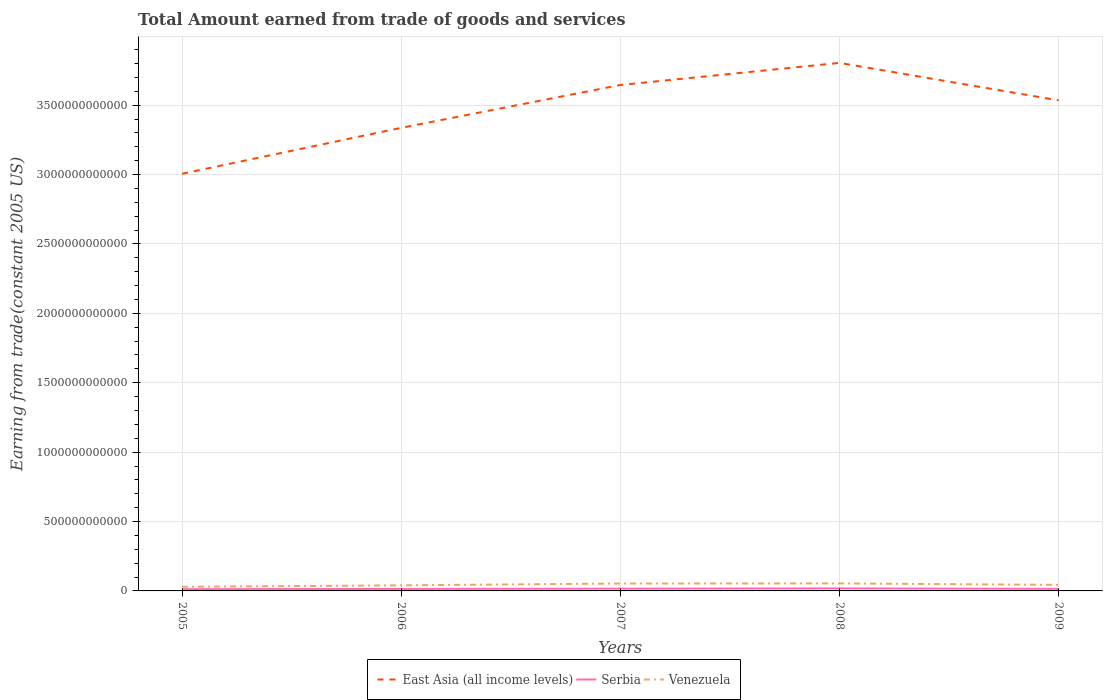How many different coloured lines are there?
Make the answer very short. 3. Across all years, what is the maximum total amount earned by trading goods and services in Serbia?
Provide a succinct answer. 1.24e+1. In which year was the total amount earned by trading goods and services in Serbia maximum?
Ensure brevity in your answer.  2005. What is the total total amount earned by trading goods and services in Serbia in the graph?
Provide a short and direct response. -4.27e+09. What is the difference between the highest and the second highest total amount earned by trading goods and services in Venezuela?
Offer a terse response. 2.43e+1. How many years are there in the graph?
Offer a very short reply. 5. What is the difference between two consecutive major ticks on the Y-axis?
Provide a short and direct response. 5.00e+11. Does the graph contain any zero values?
Provide a succinct answer. No. Where does the legend appear in the graph?
Ensure brevity in your answer.  Bottom center. How many legend labels are there?
Your answer should be compact. 3. How are the legend labels stacked?
Your answer should be compact. Horizontal. What is the title of the graph?
Your answer should be compact. Total Amount earned from trade of goods and services. What is the label or title of the X-axis?
Ensure brevity in your answer.  Years. What is the label or title of the Y-axis?
Offer a very short reply. Earning from trade(constant 2005 US). What is the Earning from trade(constant 2005 US) in East Asia (all income levels) in 2005?
Ensure brevity in your answer.  3.01e+12. What is the Earning from trade(constant 2005 US) in Serbia in 2005?
Offer a very short reply. 1.24e+1. What is the Earning from trade(constant 2005 US) of Venezuela in 2005?
Keep it short and to the point. 2.98e+1. What is the Earning from trade(constant 2005 US) in East Asia (all income levels) in 2006?
Keep it short and to the point. 3.34e+12. What is the Earning from trade(constant 2005 US) of Serbia in 2006?
Your answer should be compact. 1.42e+1. What is the Earning from trade(constant 2005 US) of Venezuela in 2006?
Your answer should be very brief. 4.01e+1. What is the Earning from trade(constant 2005 US) in East Asia (all income levels) in 2007?
Your answer should be very brief. 3.65e+12. What is the Earning from trade(constant 2005 US) of Serbia in 2007?
Offer a very short reply. 1.65e+1. What is the Earning from trade(constant 2005 US) in Venezuela in 2007?
Your response must be concise. 5.34e+1. What is the Earning from trade(constant 2005 US) in East Asia (all income levels) in 2008?
Make the answer very short. 3.80e+12. What is the Earning from trade(constant 2005 US) in Serbia in 2008?
Your response must be concise. 1.85e+1. What is the Earning from trade(constant 2005 US) in Venezuela in 2008?
Make the answer very short. 5.41e+1. What is the Earning from trade(constant 2005 US) in East Asia (all income levels) in 2009?
Your response must be concise. 3.53e+12. What is the Earning from trade(constant 2005 US) of Serbia in 2009?
Offer a terse response. 1.49e+1. What is the Earning from trade(constant 2005 US) in Venezuela in 2009?
Provide a short and direct response. 4.35e+1. Across all years, what is the maximum Earning from trade(constant 2005 US) in East Asia (all income levels)?
Your answer should be very brief. 3.80e+12. Across all years, what is the maximum Earning from trade(constant 2005 US) in Serbia?
Keep it short and to the point. 1.85e+1. Across all years, what is the maximum Earning from trade(constant 2005 US) in Venezuela?
Offer a terse response. 5.41e+1. Across all years, what is the minimum Earning from trade(constant 2005 US) in East Asia (all income levels)?
Offer a very short reply. 3.01e+12. Across all years, what is the minimum Earning from trade(constant 2005 US) of Serbia?
Provide a succinct answer. 1.24e+1. Across all years, what is the minimum Earning from trade(constant 2005 US) in Venezuela?
Make the answer very short. 2.98e+1. What is the total Earning from trade(constant 2005 US) in East Asia (all income levels) in the graph?
Your answer should be compact. 1.73e+13. What is the total Earning from trade(constant 2005 US) in Serbia in the graph?
Your response must be concise. 7.65e+1. What is the total Earning from trade(constant 2005 US) in Venezuela in the graph?
Offer a terse response. 2.21e+11. What is the difference between the Earning from trade(constant 2005 US) of East Asia (all income levels) in 2005 and that in 2006?
Provide a succinct answer. -3.31e+11. What is the difference between the Earning from trade(constant 2005 US) of Serbia in 2005 and that in 2006?
Offer a terse response. -1.85e+09. What is the difference between the Earning from trade(constant 2005 US) in Venezuela in 2005 and that in 2006?
Provide a short and direct response. -1.04e+1. What is the difference between the Earning from trade(constant 2005 US) in East Asia (all income levels) in 2005 and that in 2007?
Your answer should be very brief. -6.40e+11. What is the difference between the Earning from trade(constant 2005 US) in Serbia in 2005 and that in 2007?
Provide a short and direct response. -4.13e+09. What is the difference between the Earning from trade(constant 2005 US) of Venezuela in 2005 and that in 2007?
Your answer should be very brief. -2.36e+1. What is the difference between the Earning from trade(constant 2005 US) of East Asia (all income levels) in 2005 and that in 2008?
Your answer should be very brief. -7.99e+11. What is the difference between the Earning from trade(constant 2005 US) of Serbia in 2005 and that in 2008?
Keep it short and to the point. -6.12e+09. What is the difference between the Earning from trade(constant 2005 US) in Venezuela in 2005 and that in 2008?
Keep it short and to the point. -2.43e+1. What is the difference between the Earning from trade(constant 2005 US) in East Asia (all income levels) in 2005 and that in 2009?
Your answer should be very brief. -5.29e+11. What is the difference between the Earning from trade(constant 2005 US) of Serbia in 2005 and that in 2009?
Give a very brief answer. -2.49e+09. What is the difference between the Earning from trade(constant 2005 US) in Venezuela in 2005 and that in 2009?
Give a very brief answer. -1.37e+1. What is the difference between the Earning from trade(constant 2005 US) in East Asia (all income levels) in 2006 and that in 2007?
Keep it short and to the point. -3.09e+11. What is the difference between the Earning from trade(constant 2005 US) of Serbia in 2006 and that in 2007?
Offer a terse response. -2.29e+09. What is the difference between the Earning from trade(constant 2005 US) of Venezuela in 2006 and that in 2007?
Your answer should be very brief. -1.32e+1. What is the difference between the Earning from trade(constant 2005 US) of East Asia (all income levels) in 2006 and that in 2008?
Your response must be concise. -4.68e+11. What is the difference between the Earning from trade(constant 2005 US) of Serbia in 2006 and that in 2008?
Ensure brevity in your answer.  -4.27e+09. What is the difference between the Earning from trade(constant 2005 US) in Venezuela in 2006 and that in 2008?
Offer a terse response. -1.40e+1. What is the difference between the Earning from trade(constant 2005 US) in East Asia (all income levels) in 2006 and that in 2009?
Give a very brief answer. -1.98e+11. What is the difference between the Earning from trade(constant 2005 US) in Serbia in 2006 and that in 2009?
Keep it short and to the point. -6.40e+08. What is the difference between the Earning from trade(constant 2005 US) of Venezuela in 2006 and that in 2009?
Your response must be concise. -3.39e+09. What is the difference between the Earning from trade(constant 2005 US) of East Asia (all income levels) in 2007 and that in 2008?
Offer a terse response. -1.59e+11. What is the difference between the Earning from trade(constant 2005 US) in Serbia in 2007 and that in 2008?
Give a very brief answer. -1.98e+09. What is the difference between the Earning from trade(constant 2005 US) of Venezuela in 2007 and that in 2008?
Keep it short and to the point. -7.27e+08. What is the difference between the Earning from trade(constant 2005 US) of East Asia (all income levels) in 2007 and that in 2009?
Provide a succinct answer. 1.11e+11. What is the difference between the Earning from trade(constant 2005 US) of Serbia in 2007 and that in 2009?
Your answer should be very brief. 1.65e+09. What is the difference between the Earning from trade(constant 2005 US) of Venezuela in 2007 and that in 2009?
Make the answer very short. 9.86e+09. What is the difference between the Earning from trade(constant 2005 US) in East Asia (all income levels) in 2008 and that in 2009?
Give a very brief answer. 2.70e+11. What is the difference between the Earning from trade(constant 2005 US) of Serbia in 2008 and that in 2009?
Your answer should be compact. 3.63e+09. What is the difference between the Earning from trade(constant 2005 US) in Venezuela in 2008 and that in 2009?
Provide a short and direct response. 1.06e+1. What is the difference between the Earning from trade(constant 2005 US) of East Asia (all income levels) in 2005 and the Earning from trade(constant 2005 US) of Serbia in 2006?
Offer a terse response. 2.99e+12. What is the difference between the Earning from trade(constant 2005 US) in East Asia (all income levels) in 2005 and the Earning from trade(constant 2005 US) in Venezuela in 2006?
Your answer should be compact. 2.97e+12. What is the difference between the Earning from trade(constant 2005 US) of Serbia in 2005 and the Earning from trade(constant 2005 US) of Venezuela in 2006?
Your response must be concise. -2.78e+1. What is the difference between the Earning from trade(constant 2005 US) of East Asia (all income levels) in 2005 and the Earning from trade(constant 2005 US) of Serbia in 2007?
Your response must be concise. 2.99e+12. What is the difference between the Earning from trade(constant 2005 US) in East Asia (all income levels) in 2005 and the Earning from trade(constant 2005 US) in Venezuela in 2007?
Ensure brevity in your answer.  2.95e+12. What is the difference between the Earning from trade(constant 2005 US) of Serbia in 2005 and the Earning from trade(constant 2005 US) of Venezuela in 2007?
Make the answer very short. -4.10e+1. What is the difference between the Earning from trade(constant 2005 US) in East Asia (all income levels) in 2005 and the Earning from trade(constant 2005 US) in Serbia in 2008?
Provide a short and direct response. 2.99e+12. What is the difference between the Earning from trade(constant 2005 US) of East Asia (all income levels) in 2005 and the Earning from trade(constant 2005 US) of Venezuela in 2008?
Your answer should be very brief. 2.95e+12. What is the difference between the Earning from trade(constant 2005 US) in Serbia in 2005 and the Earning from trade(constant 2005 US) in Venezuela in 2008?
Ensure brevity in your answer.  -4.17e+1. What is the difference between the Earning from trade(constant 2005 US) of East Asia (all income levels) in 2005 and the Earning from trade(constant 2005 US) of Serbia in 2009?
Offer a very short reply. 2.99e+12. What is the difference between the Earning from trade(constant 2005 US) of East Asia (all income levels) in 2005 and the Earning from trade(constant 2005 US) of Venezuela in 2009?
Keep it short and to the point. 2.96e+12. What is the difference between the Earning from trade(constant 2005 US) of Serbia in 2005 and the Earning from trade(constant 2005 US) of Venezuela in 2009?
Provide a succinct answer. -3.12e+1. What is the difference between the Earning from trade(constant 2005 US) in East Asia (all income levels) in 2006 and the Earning from trade(constant 2005 US) in Serbia in 2007?
Your response must be concise. 3.32e+12. What is the difference between the Earning from trade(constant 2005 US) of East Asia (all income levels) in 2006 and the Earning from trade(constant 2005 US) of Venezuela in 2007?
Your response must be concise. 3.28e+12. What is the difference between the Earning from trade(constant 2005 US) in Serbia in 2006 and the Earning from trade(constant 2005 US) in Venezuela in 2007?
Make the answer very short. -3.92e+1. What is the difference between the Earning from trade(constant 2005 US) in East Asia (all income levels) in 2006 and the Earning from trade(constant 2005 US) in Serbia in 2008?
Offer a terse response. 3.32e+12. What is the difference between the Earning from trade(constant 2005 US) of East Asia (all income levels) in 2006 and the Earning from trade(constant 2005 US) of Venezuela in 2008?
Provide a succinct answer. 3.28e+12. What is the difference between the Earning from trade(constant 2005 US) in Serbia in 2006 and the Earning from trade(constant 2005 US) in Venezuela in 2008?
Your answer should be compact. -3.99e+1. What is the difference between the Earning from trade(constant 2005 US) in East Asia (all income levels) in 2006 and the Earning from trade(constant 2005 US) in Serbia in 2009?
Ensure brevity in your answer.  3.32e+12. What is the difference between the Earning from trade(constant 2005 US) in East Asia (all income levels) in 2006 and the Earning from trade(constant 2005 US) in Venezuela in 2009?
Give a very brief answer. 3.29e+12. What is the difference between the Earning from trade(constant 2005 US) of Serbia in 2006 and the Earning from trade(constant 2005 US) of Venezuela in 2009?
Provide a short and direct response. -2.93e+1. What is the difference between the Earning from trade(constant 2005 US) in East Asia (all income levels) in 2007 and the Earning from trade(constant 2005 US) in Serbia in 2008?
Ensure brevity in your answer.  3.63e+12. What is the difference between the Earning from trade(constant 2005 US) of East Asia (all income levels) in 2007 and the Earning from trade(constant 2005 US) of Venezuela in 2008?
Your answer should be compact. 3.59e+12. What is the difference between the Earning from trade(constant 2005 US) of Serbia in 2007 and the Earning from trade(constant 2005 US) of Venezuela in 2008?
Your answer should be compact. -3.76e+1. What is the difference between the Earning from trade(constant 2005 US) in East Asia (all income levels) in 2007 and the Earning from trade(constant 2005 US) in Serbia in 2009?
Ensure brevity in your answer.  3.63e+12. What is the difference between the Earning from trade(constant 2005 US) of East Asia (all income levels) in 2007 and the Earning from trade(constant 2005 US) of Venezuela in 2009?
Provide a succinct answer. 3.60e+12. What is the difference between the Earning from trade(constant 2005 US) of Serbia in 2007 and the Earning from trade(constant 2005 US) of Venezuela in 2009?
Your answer should be very brief. -2.70e+1. What is the difference between the Earning from trade(constant 2005 US) in East Asia (all income levels) in 2008 and the Earning from trade(constant 2005 US) in Serbia in 2009?
Provide a short and direct response. 3.79e+12. What is the difference between the Earning from trade(constant 2005 US) of East Asia (all income levels) in 2008 and the Earning from trade(constant 2005 US) of Venezuela in 2009?
Keep it short and to the point. 3.76e+12. What is the difference between the Earning from trade(constant 2005 US) of Serbia in 2008 and the Earning from trade(constant 2005 US) of Venezuela in 2009?
Ensure brevity in your answer.  -2.50e+1. What is the average Earning from trade(constant 2005 US) of East Asia (all income levels) per year?
Keep it short and to the point. 3.47e+12. What is the average Earning from trade(constant 2005 US) in Serbia per year?
Make the answer very short. 1.53e+1. What is the average Earning from trade(constant 2005 US) of Venezuela per year?
Offer a very short reply. 4.42e+1. In the year 2005, what is the difference between the Earning from trade(constant 2005 US) of East Asia (all income levels) and Earning from trade(constant 2005 US) of Serbia?
Make the answer very short. 2.99e+12. In the year 2005, what is the difference between the Earning from trade(constant 2005 US) in East Asia (all income levels) and Earning from trade(constant 2005 US) in Venezuela?
Your response must be concise. 2.98e+12. In the year 2005, what is the difference between the Earning from trade(constant 2005 US) in Serbia and Earning from trade(constant 2005 US) in Venezuela?
Your answer should be very brief. -1.74e+1. In the year 2006, what is the difference between the Earning from trade(constant 2005 US) in East Asia (all income levels) and Earning from trade(constant 2005 US) in Serbia?
Your answer should be compact. 3.32e+12. In the year 2006, what is the difference between the Earning from trade(constant 2005 US) in East Asia (all income levels) and Earning from trade(constant 2005 US) in Venezuela?
Provide a short and direct response. 3.30e+12. In the year 2006, what is the difference between the Earning from trade(constant 2005 US) of Serbia and Earning from trade(constant 2005 US) of Venezuela?
Ensure brevity in your answer.  -2.59e+1. In the year 2007, what is the difference between the Earning from trade(constant 2005 US) in East Asia (all income levels) and Earning from trade(constant 2005 US) in Serbia?
Offer a very short reply. 3.63e+12. In the year 2007, what is the difference between the Earning from trade(constant 2005 US) of East Asia (all income levels) and Earning from trade(constant 2005 US) of Venezuela?
Give a very brief answer. 3.59e+12. In the year 2007, what is the difference between the Earning from trade(constant 2005 US) of Serbia and Earning from trade(constant 2005 US) of Venezuela?
Ensure brevity in your answer.  -3.69e+1. In the year 2008, what is the difference between the Earning from trade(constant 2005 US) of East Asia (all income levels) and Earning from trade(constant 2005 US) of Serbia?
Your answer should be very brief. 3.79e+12. In the year 2008, what is the difference between the Earning from trade(constant 2005 US) of East Asia (all income levels) and Earning from trade(constant 2005 US) of Venezuela?
Your answer should be compact. 3.75e+12. In the year 2008, what is the difference between the Earning from trade(constant 2005 US) in Serbia and Earning from trade(constant 2005 US) in Venezuela?
Provide a short and direct response. -3.56e+1. In the year 2009, what is the difference between the Earning from trade(constant 2005 US) in East Asia (all income levels) and Earning from trade(constant 2005 US) in Serbia?
Provide a short and direct response. 3.52e+12. In the year 2009, what is the difference between the Earning from trade(constant 2005 US) in East Asia (all income levels) and Earning from trade(constant 2005 US) in Venezuela?
Provide a succinct answer. 3.49e+12. In the year 2009, what is the difference between the Earning from trade(constant 2005 US) in Serbia and Earning from trade(constant 2005 US) in Venezuela?
Provide a short and direct response. -2.87e+1. What is the ratio of the Earning from trade(constant 2005 US) in East Asia (all income levels) in 2005 to that in 2006?
Offer a terse response. 0.9. What is the ratio of the Earning from trade(constant 2005 US) of Serbia in 2005 to that in 2006?
Your response must be concise. 0.87. What is the ratio of the Earning from trade(constant 2005 US) of Venezuela in 2005 to that in 2006?
Your response must be concise. 0.74. What is the ratio of the Earning from trade(constant 2005 US) in East Asia (all income levels) in 2005 to that in 2007?
Your response must be concise. 0.82. What is the ratio of the Earning from trade(constant 2005 US) in Serbia in 2005 to that in 2007?
Your answer should be compact. 0.75. What is the ratio of the Earning from trade(constant 2005 US) of Venezuela in 2005 to that in 2007?
Ensure brevity in your answer.  0.56. What is the ratio of the Earning from trade(constant 2005 US) in East Asia (all income levels) in 2005 to that in 2008?
Offer a very short reply. 0.79. What is the ratio of the Earning from trade(constant 2005 US) of Serbia in 2005 to that in 2008?
Provide a short and direct response. 0.67. What is the ratio of the Earning from trade(constant 2005 US) of Venezuela in 2005 to that in 2008?
Offer a very short reply. 0.55. What is the ratio of the Earning from trade(constant 2005 US) of East Asia (all income levels) in 2005 to that in 2009?
Give a very brief answer. 0.85. What is the ratio of the Earning from trade(constant 2005 US) of Serbia in 2005 to that in 2009?
Offer a terse response. 0.83. What is the ratio of the Earning from trade(constant 2005 US) of Venezuela in 2005 to that in 2009?
Give a very brief answer. 0.68. What is the ratio of the Earning from trade(constant 2005 US) of East Asia (all income levels) in 2006 to that in 2007?
Provide a succinct answer. 0.92. What is the ratio of the Earning from trade(constant 2005 US) of Serbia in 2006 to that in 2007?
Give a very brief answer. 0.86. What is the ratio of the Earning from trade(constant 2005 US) in Venezuela in 2006 to that in 2007?
Make the answer very short. 0.75. What is the ratio of the Earning from trade(constant 2005 US) of East Asia (all income levels) in 2006 to that in 2008?
Provide a short and direct response. 0.88. What is the ratio of the Earning from trade(constant 2005 US) of Serbia in 2006 to that in 2008?
Offer a very short reply. 0.77. What is the ratio of the Earning from trade(constant 2005 US) in Venezuela in 2006 to that in 2008?
Your answer should be very brief. 0.74. What is the ratio of the Earning from trade(constant 2005 US) in East Asia (all income levels) in 2006 to that in 2009?
Your answer should be compact. 0.94. What is the ratio of the Earning from trade(constant 2005 US) in Serbia in 2006 to that in 2009?
Your answer should be compact. 0.96. What is the ratio of the Earning from trade(constant 2005 US) in Venezuela in 2006 to that in 2009?
Give a very brief answer. 0.92. What is the ratio of the Earning from trade(constant 2005 US) of East Asia (all income levels) in 2007 to that in 2008?
Give a very brief answer. 0.96. What is the ratio of the Earning from trade(constant 2005 US) in Serbia in 2007 to that in 2008?
Your response must be concise. 0.89. What is the ratio of the Earning from trade(constant 2005 US) of Venezuela in 2007 to that in 2008?
Offer a terse response. 0.99. What is the ratio of the Earning from trade(constant 2005 US) of East Asia (all income levels) in 2007 to that in 2009?
Keep it short and to the point. 1.03. What is the ratio of the Earning from trade(constant 2005 US) in Serbia in 2007 to that in 2009?
Offer a terse response. 1.11. What is the ratio of the Earning from trade(constant 2005 US) in Venezuela in 2007 to that in 2009?
Provide a short and direct response. 1.23. What is the ratio of the Earning from trade(constant 2005 US) of East Asia (all income levels) in 2008 to that in 2009?
Ensure brevity in your answer.  1.08. What is the ratio of the Earning from trade(constant 2005 US) in Serbia in 2008 to that in 2009?
Your response must be concise. 1.24. What is the ratio of the Earning from trade(constant 2005 US) in Venezuela in 2008 to that in 2009?
Offer a terse response. 1.24. What is the difference between the highest and the second highest Earning from trade(constant 2005 US) in East Asia (all income levels)?
Provide a succinct answer. 1.59e+11. What is the difference between the highest and the second highest Earning from trade(constant 2005 US) in Serbia?
Provide a succinct answer. 1.98e+09. What is the difference between the highest and the second highest Earning from trade(constant 2005 US) of Venezuela?
Keep it short and to the point. 7.27e+08. What is the difference between the highest and the lowest Earning from trade(constant 2005 US) in East Asia (all income levels)?
Ensure brevity in your answer.  7.99e+11. What is the difference between the highest and the lowest Earning from trade(constant 2005 US) of Serbia?
Ensure brevity in your answer.  6.12e+09. What is the difference between the highest and the lowest Earning from trade(constant 2005 US) of Venezuela?
Provide a succinct answer. 2.43e+1. 